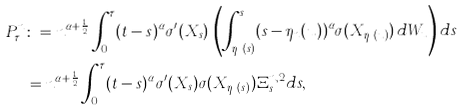<formula> <loc_0><loc_0><loc_500><loc_500>P ^ { n } _ { \tau } & \colon = n ^ { \alpha + \frac { 1 } { 2 } } \int ^ { \tau } _ { 0 } ( t - s ) ^ { \alpha } \sigma ^ { \prime } ( X _ { s } ) \, \left ( \int ^ { s } _ { \eta _ { n } ( s ) } ( s - \eta _ { n } ( u ) ) ^ { \alpha } \sigma ( X _ { \eta _ { n } ( u ) } ) \, d W _ { u } \right ) d s \\ & = n ^ { \alpha + \frac { 1 } { 2 } } \int ^ { \tau } _ { 0 } ( t - s ) ^ { \alpha } \sigma ^ { \prime } ( X _ { s } ) \sigma ( X _ { \eta _ { n } ( s ) } ) \Xi ^ { n , 2 } _ { s } d s ,</formula> 